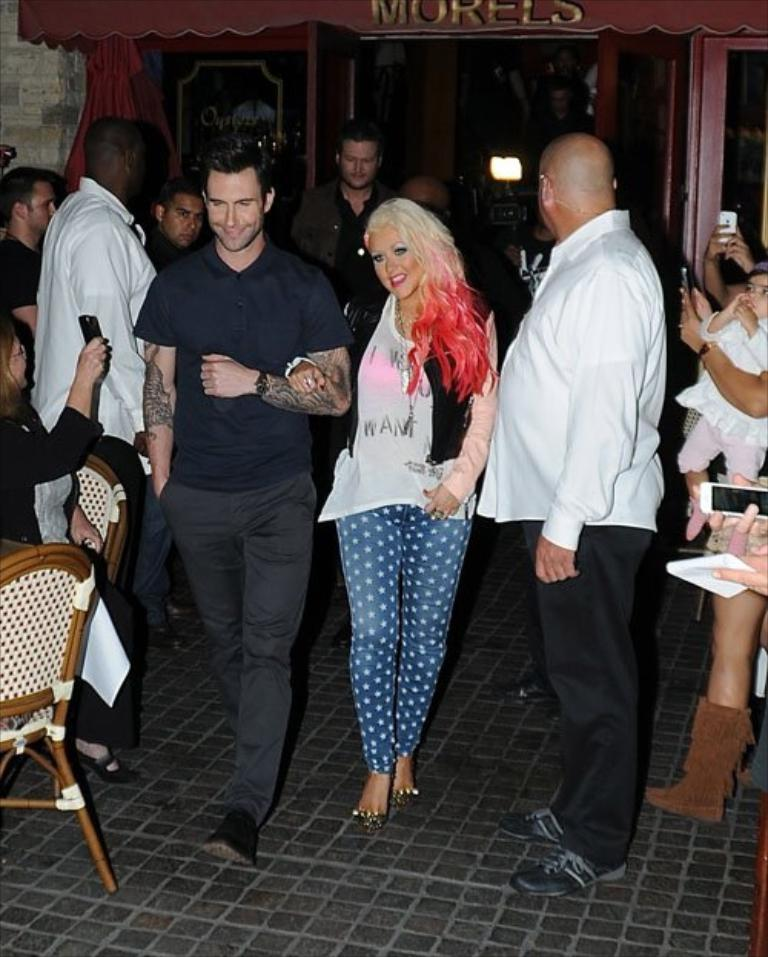What is the primary activity of the people in the image? The people in the image are either standing or sitting on chairs. Can you describe the posture of some of the people in the image? Some people are standing, while others are sitting on chairs. What objects are being held by some of the people in the image? Some people are holding mobile phones in their hands. What type of queen is present in the image? There is no queen present in the image; it features people standing or sitting on chairs and holding mobile phones. Can you tell me how many spies are visible in the image? There are no spies visible in the image; it features people standing or sitting on chairs and holding mobile phones. 